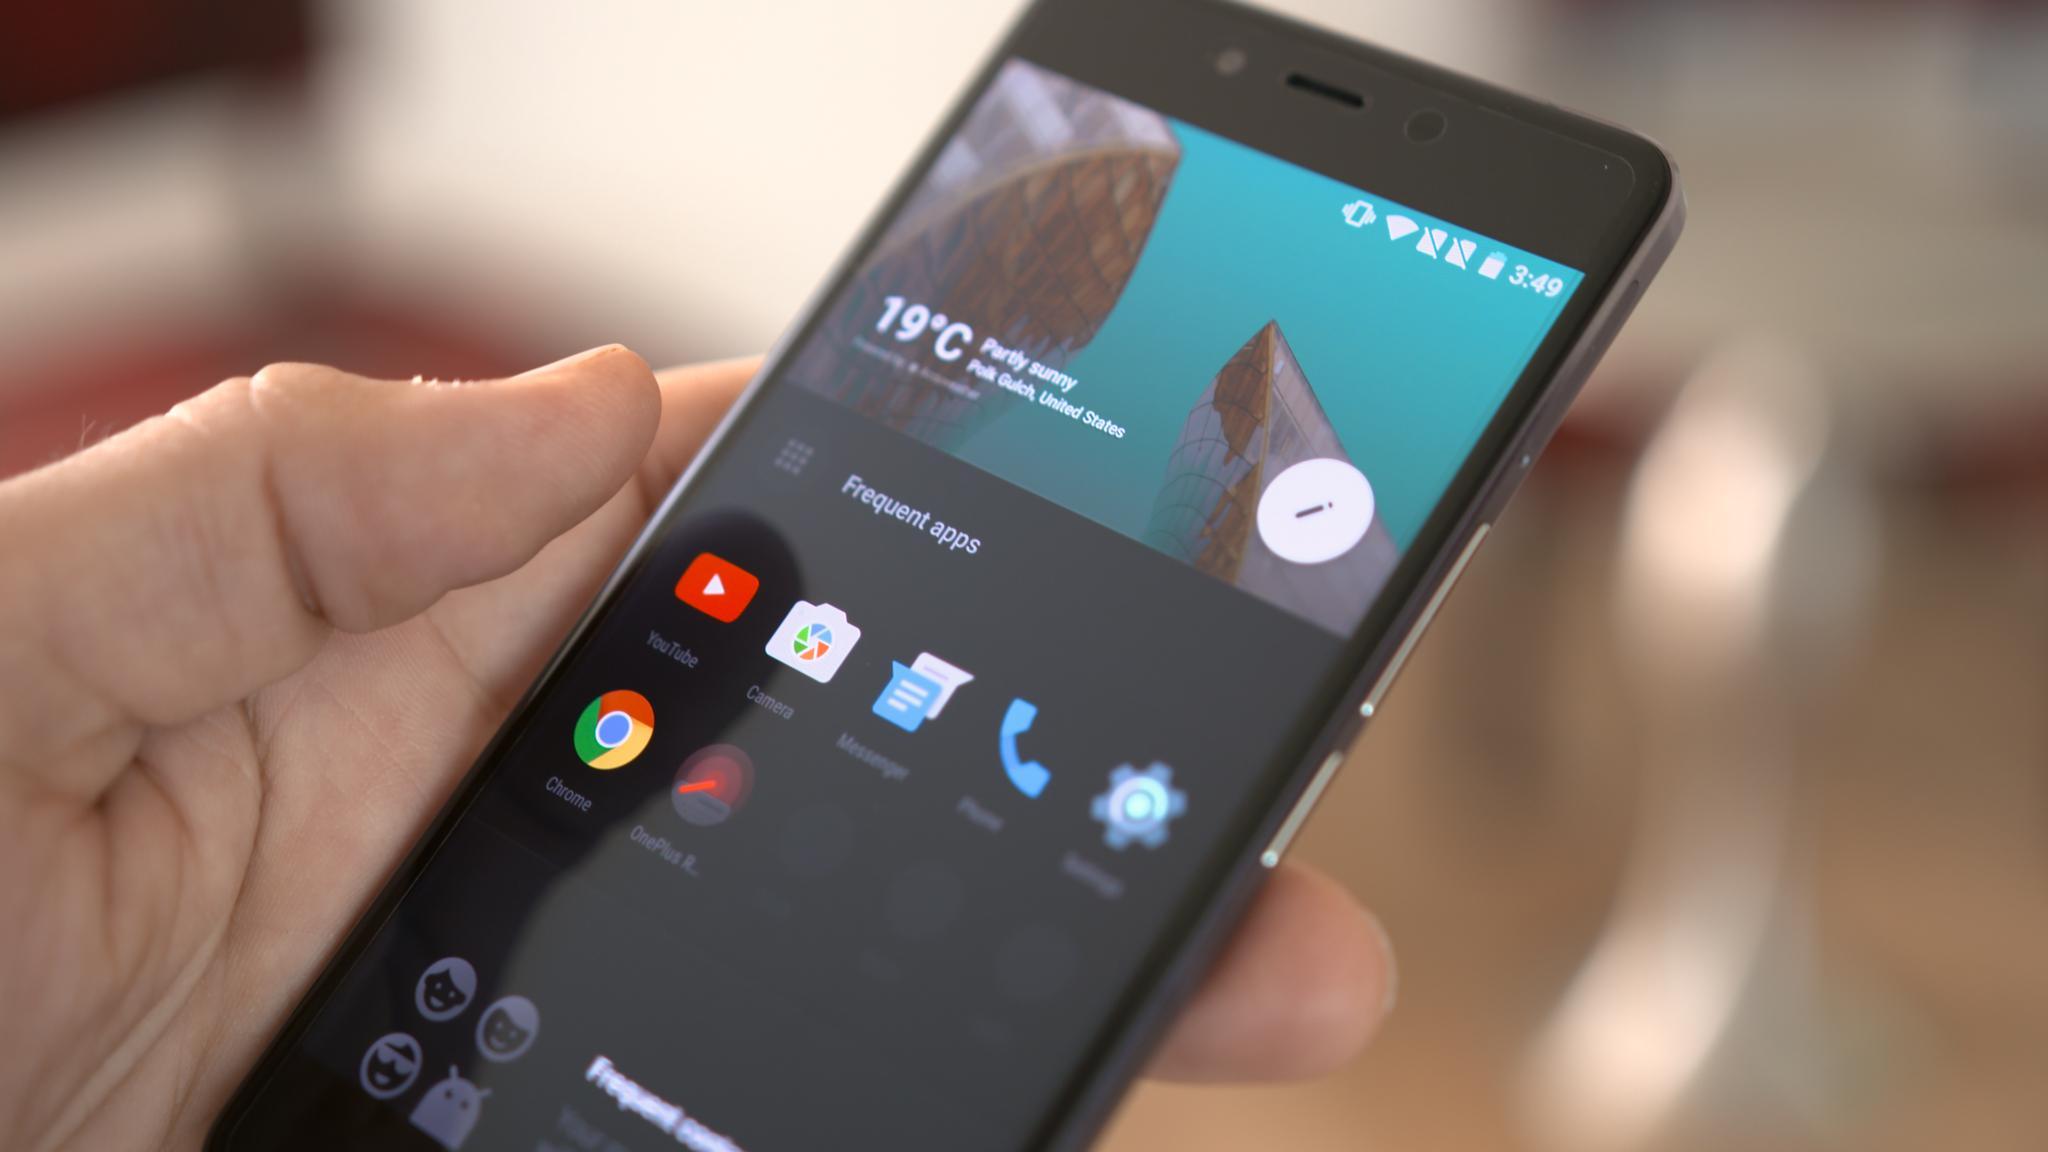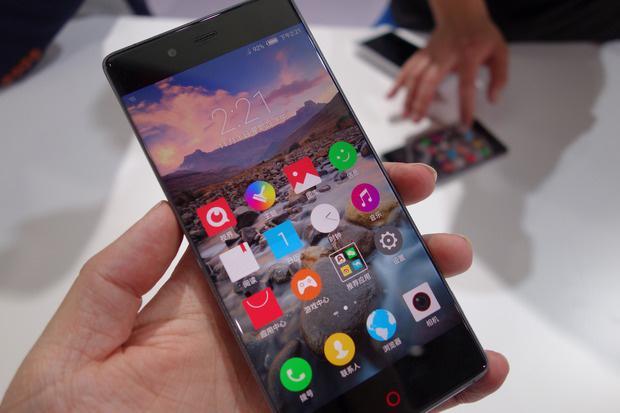The first image is the image on the left, the second image is the image on the right. For the images displayed, is the sentence "There are three hands." factually correct? Answer yes or no. Yes. The first image is the image on the left, the second image is the image on the right. For the images displayed, is the sentence "There are two phones and one hand." factually correct? Answer yes or no. No. 